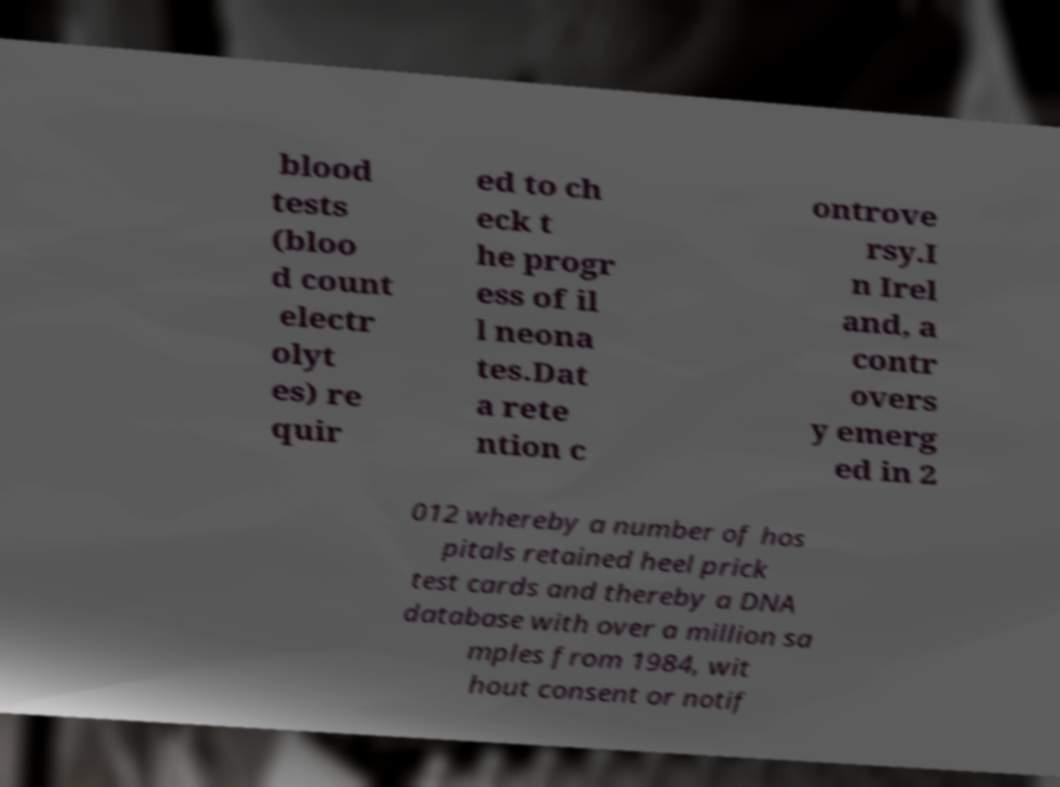Please identify and transcribe the text found in this image. blood tests (bloo d count electr olyt es) re quir ed to ch eck t he progr ess of il l neona tes.Dat a rete ntion c ontrove rsy.I n Irel and, a contr overs y emerg ed in 2 012 whereby a number of hos pitals retained heel prick test cards and thereby a DNA database with over a million sa mples from 1984, wit hout consent or notif 